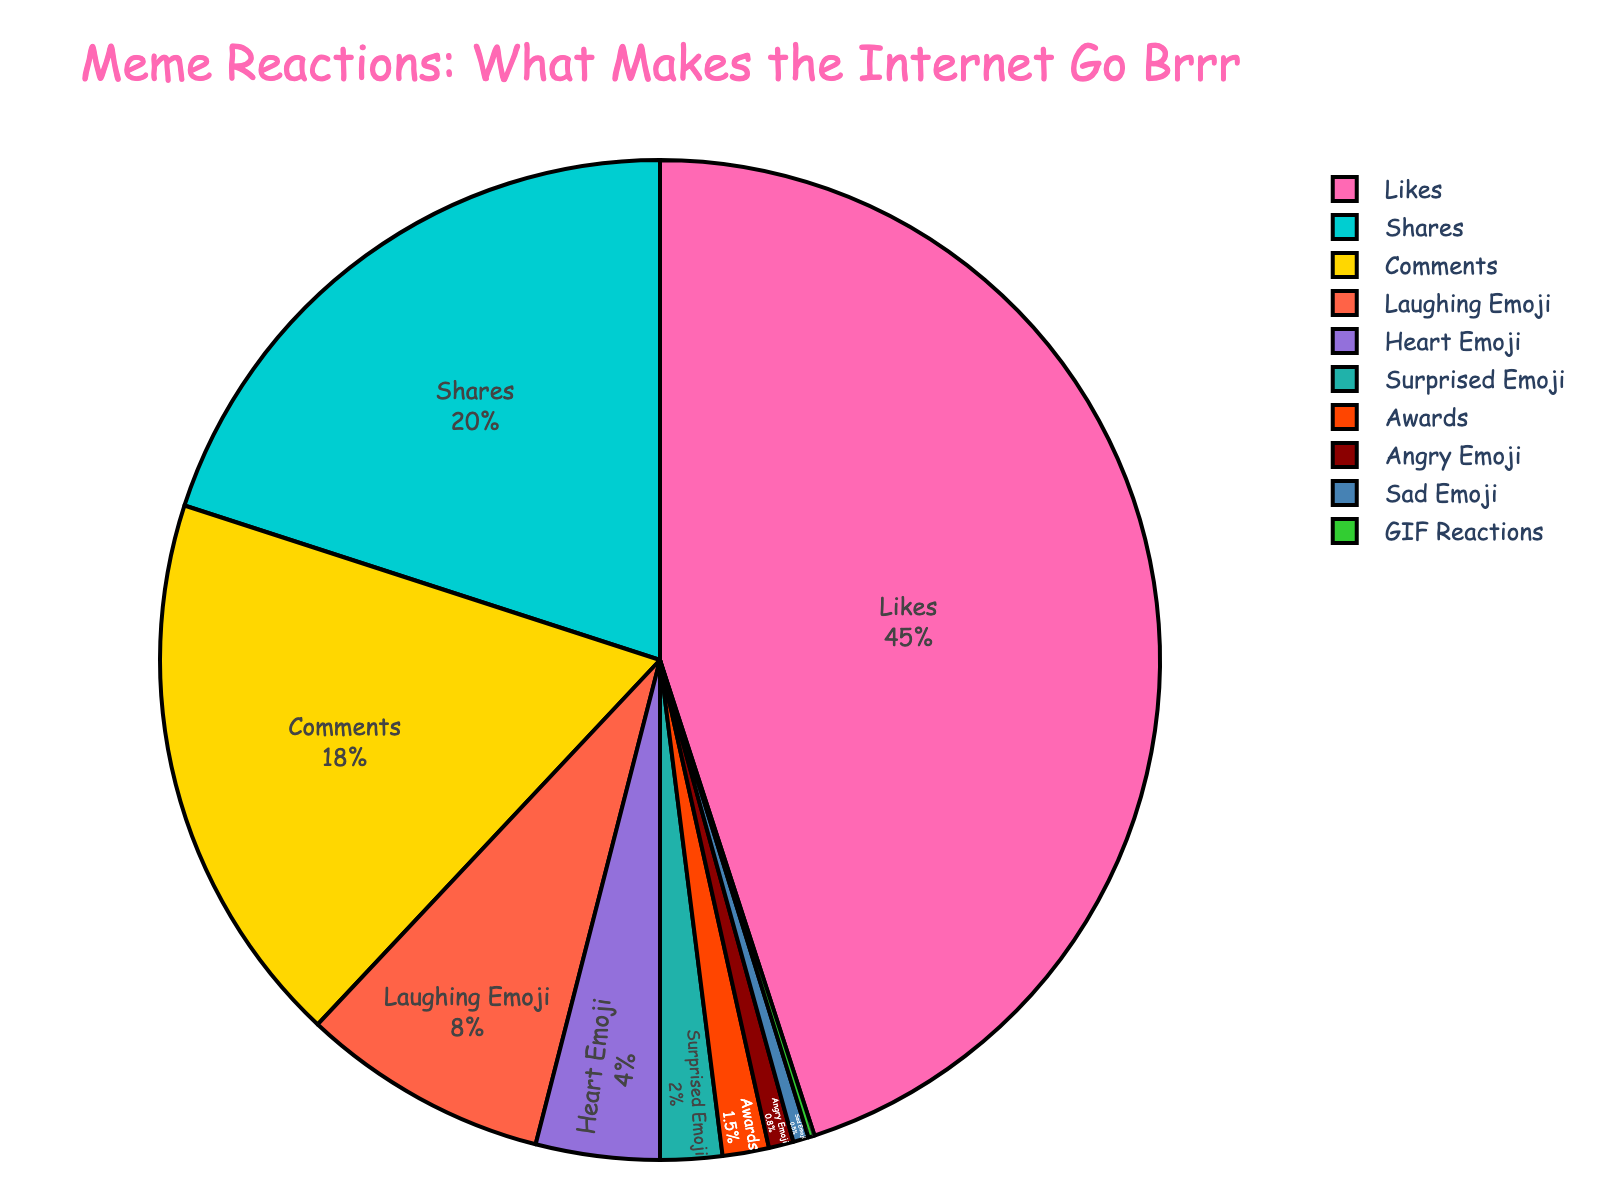What's the total percentage of reactions apart from Likes and Shares? First, we add all the percentages given. The total is 100%. Then, sum the percentages for Likes and Shares, which is 45% + 20% = 65%. Subtract this from the total percentage: 100% - 65% = 35%.
Answer: 35% Which reaction received the highest percentage? By observing the pie chart, it's clear that "Likes" takes up the largest portion of the chart. The percentage for "Likes" is 45%.
Answer: Likes How much more percentage do Likes and Shares combined have over Comments? Add the percentages of Likes and Shares, which gives us 45% + 20% = 65%. Compare this sum with the percentage for Comments, which is 18%. Subtract Comments from the combined Likes and Shares: 65% - 18% = 47%.
Answer: 47% Which reaction has the smallest percentage? The smallest segment on the pie chart represents "GIF Reactions" with a percentage of 0.2%.
Answer: GIF Reactions What's the combined percentage of the Laughing Emoji and Heart Emoji reactions? Simply add the percentages of Laughing Emoji and Heart Emoji reactions: 8% + 4% = 12%.
Answer: 12% Are Laughing Emoji reactions greater than the total of Angry Emoji and Sad Emoji reactions? First, check the percentages for Laughing Emoji (8%), Angry Emoji (0.8%), and Sad Emoji (0.5%). Add Angry Emoji and Sad Emoji: 0.8% + 0.5% = 1.3%. Compare Laughing Emoji (8%) to this total. 8% is greater than 1.3%.
Answer: Yes What's the ratio of Likes to Shares? To find the ratio, take the percentage of Likes (45%) and divide by the percentage of Shares (20%). The ratio is 45 / 20, which simplifies to 9:4.
Answer: 9:4 What's the difference in percentage between the Heart Emoji and the Surprised Emoji reactions? Look at the pie chart to find Heart Emoji (4%) and Surprised Emoji (2%). Subtract Surprised Emoji from Heart Emoji: 4% - 2% = 2%.
Answer: 2% Does the percentage of Awards received exceed that of Angry Emoji plus Sad Emoji? Check the percentages of Awards (1.5%), Angry Emoji (0.8%), and Sad Emoji (0.5%). Add Angry Emoji and Sad Emoji: 0.8% + 0.5% = 1.3%. Compare this total with Awards (1.5%). Since 1.5% is greater than 1.3%, Awards received do exceed.
Answer: Yes What's the visual difference between the segments for Sad Emoji and GIF Reactions? According to the pie chart, the Sad Emoji segment is larger than the GIF Reactions segment. Sad Emoji has a 0.5% representation while GIF Reactions have 0.2%.
Answer: Sad Emoji segment is larger 